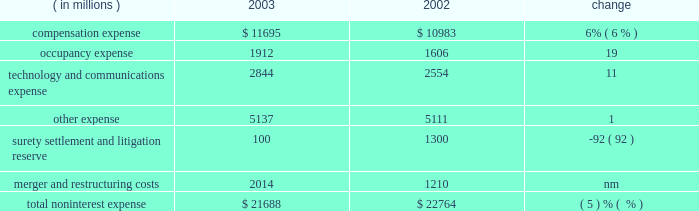Management 2019s discussion and analysis j.p .
Morgan chase & co .
26 j.p .
Morgan chase & co .
/ 2003 annual report $ 41.7 billion .
Nii was reduced by a lower volume of commercial loans and lower spreads on investment securities .
As a compo- nent of nii , trading-related net interest income of $ 2.1 billion was up 13% ( 13 % ) from 2002 due to a change in the composition of , and growth in , trading assets .
The firm 2019s total average interest-earning assets in 2003 were $ 590 billion , up 6% ( 6 % ) from the prior year .
The net interest yield on these assets , on a fully taxable-equivalent basis , was 2.10% ( 2.10 % ) , compared with 2.09% ( 2.09 % ) in the prior year .
Noninterest expense year ended december 31 .
Technology and communications expense in 2003 , technology and communications expense was 11% ( 11 % ) above the prior-year level .
The increase was primarily due to a shift in expenses : costs that were previously associated with compensation and other expenses shifted , upon the commence- ment of the ibm outsourcing agreement , to technology and communications expense .
Also contributing to the increase were higher costs related to software amortization .
For a further dis- cussion of the ibm outsourcing agreement , see support units and corporate on page 44 of this annual report .
Other expense other expense in 2003 rose slightly from the prior year , reflecting higher outside services .
For a table showing the components of other expense , see note 8 on page 96 of this annual report .
Surety settlement and litigation reserve the firm added $ 100 million to the enron-related litigation reserve in 2003 to supplement a $ 900 million reserve initially recorded in 2002 .
The 2002 reserve was established to cover enron-related matters , as well as certain other material litigation , proceedings and investigations in which the firm is involved .
In addition , in 2002 the firm recorded a charge of $ 400 million for the settlement of enron-related surety litigation .
Merger and restructuring costs merger and restructuring costs related to business restructurings announced after january 1 , 2002 , were recorded in their relevant expense categories .
In 2002 , merger and restructuring costs of $ 1.2 billion , for programs announced prior to january 1 , 2002 , were viewed by management as nonoperating expenses or 201cspecial items . 201d refer to note 8 on pages 95 201396 of this annual report for a further discussion of merger and restructuring costs and for a summary , by expense category and business segment , of costs incurred in 2003 and 2002 for programs announced after january 1 , 2002 .
Provision for credit losses the 2003 provision for credit losses was $ 2.8 billion lower than in 2002 , primarily reflecting continued improvement in the quality of the commercial loan portfolio and a higher volume of credit card securitizations .
For further information about the provision for credit losses and the firm 2019s management of credit risk , see the dis- cussions of net charge-offs associated with the commercial and consumer loan portfolios and the allowance for credit losses , on pages 63 201365 of this annual report .
Income tax expense income tax expense was $ 3.3 billion in 2003 , compared with $ 856 million in 2002 .
The effective tax rate in 2003 was 33% ( 33 % ) , compared with 34% ( 34 % ) in 2002 .
The tax rate decline was principally attributable to changes in the proportion of income subject to state and local taxes .
Compensation expense compensation expense in 2003 was 6% ( 6 % ) higher than in the prior year .
The increase principally reflected higher performance-related incentives , and higher pension and other postretirement benefit costs , primarily as a result of changes in actuarial assumptions .
For a detailed discussion of pension and other postretirement benefit costs , see note 6 on pages 89 201393 of this annual report .
The increase pertaining to incentives included $ 266 million as a result of adopting sfas 123 , and $ 120 million from the reversal in 2002 of previously accrued expenses for certain forfeitable key employ- ee stock awards , as discussed in note 7 on pages 93 201395 of this annual report .
Total compensation expense declined as a result of the transfer , beginning april 1 , 2003 , of 2800 employees to ibm in connection with a technology outsourcing agreement .
The total number of full-time equivalent employees at december 31 , 2003 was 93453 compared with 94335 at the prior year-end .
Occupancy expense occupancy expense of $ 1.9 billion rose 19% ( 19 % ) from 2002 .
The increase reflected costs of additional leased space in midtown manhattan and in the south and southwest regions of the united states ; higher real estate taxes in new york city ; and the cost of enhanced safety measures .
Also contributing to the increase were charges for unoccupied excess real estate of $ 270 million ; this compared with $ 120 million in 2002 , mostly in the third quarter of that year. .
What is the average compensation expense per employee in 2003? 
Computations: ((11695 * 1000000) / 93453)
Answer: 125143.12007. 